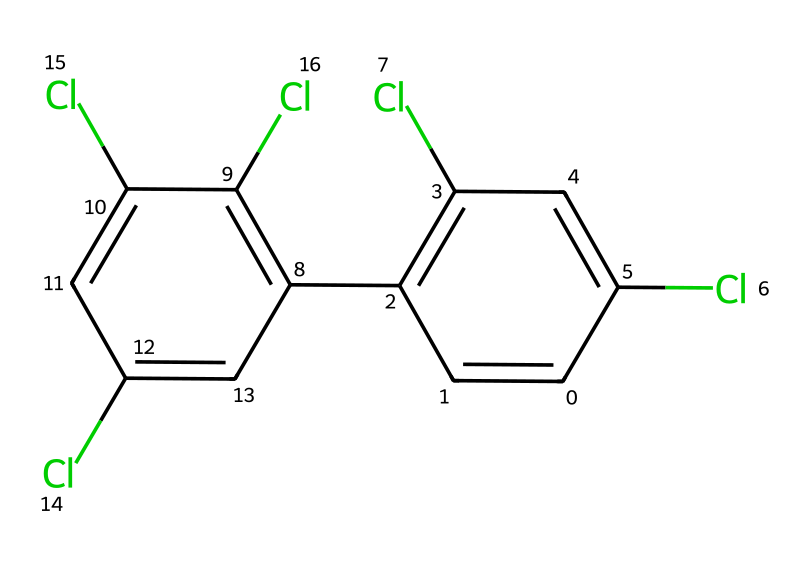How many chlorine atoms are present in this compound? By examining the SMILES representation, we can identify the occurrences of "Cl," which represents chlorine atoms. There are four instances of "Cl" in the structure, indicating the presence of four chlorine atoms.
Answer: four What is the degree of unsaturation in this compound? To calculate the degree of unsaturation, we can use the formula: Degree of Unsaturation = (2C + 2 + N - H - X)/2. Here, C is the number of carbons (12), H is the number of hydrogens (4), N is the number of nitrogens (0), and X is the number of halogens (in this case, chlorine, 4). Plugging in the numbers yields (2*12 + 2 + 0 - 4 - 4)/2 = 10/2 = 5, indicating five units of saturation loss.
Answer: five Is this compound chiral? A compound is considered chiral if it has no internal plane of symmetry and has at least one stereocenter. Analyzing the structure reveals that it contains several stereocenters due to the multiple chlorine substitutions; hence, it does not have an internal plane of symmetry. Thus, this compound is chiral.
Answer: yes What type of isomerism can be observed in this compound? Given that the compound has multiple stereocenters due to different arrangements of chlorine around carbon atoms, it exhibits geometrical isomerism. Additionally, because of its chirality, it can display optical isomerism as well. Therefore, both geometrical and optical isomerism can be observed.
Answer: geometrical and optical Which functional groups are present in the compound? The compound's primary functional group is the chlorinated phenyl rings, as indicated by the presence of multiple chlorine atoms attached to aromatic rings. The rings themselves signify that they are part of the phenyl functional group.
Answer: chlorinated phenyl rings What is the role of PCB in electrical transformers? PCBs were primarily used in electrical transformers as insulating fluids due to their excellent electrical insulating properties, chemical stability, and heat resistance. However, they have been banned in many countries due to their environmental and health hazards.
Answer: insulating fluids 